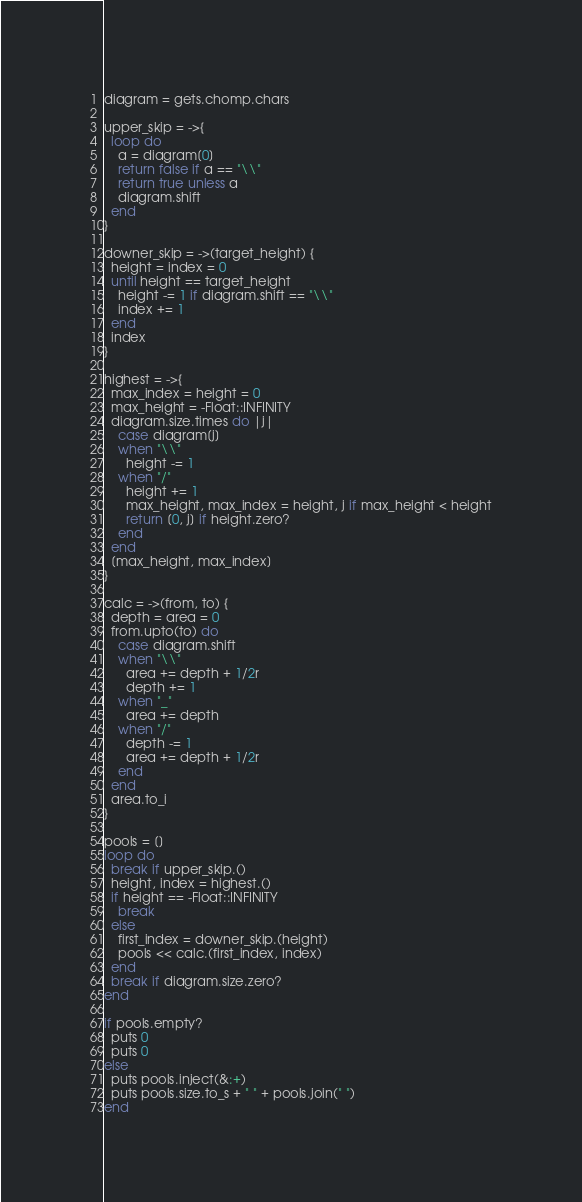Convert code to text. <code><loc_0><loc_0><loc_500><loc_500><_Ruby_>diagram = gets.chomp.chars

upper_skip = ->{
  loop do
    a = diagram[0]
    return false if a == "\\"
    return true unless a
    diagram.shift
  end
}

downer_skip = ->(target_height) {
  height = index = 0
  until height == target_height
    height -= 1 if diagram.shift == "\\"
    index += 1
  end
  index
}

highest = ->{
  max_index = height = 0
  max_height = -Float::INFINITY 
  diagram.size.times do |j|
    case diagram[j]
    when "\\"
      height -= 1
    when "/"
      height += 1
      max_height, max_index = height, j if max_height < height
      return [0, j] if height.zero?
    end
  end
  [max_height, max_index]
}

calc = ->(from, to) {
  depth = area = 0
  from.upto(to) do
    case diagram.shift
    when "\\"
      area += depth + 1/2r
      depth += 1
    when "_"
      area += depth
    when "/"
      depth -= 1
      area += depth + 1/2r
    end
  end
  area.to_i
}

pools = []
loop do
  break if upper_skip.()
  height, index = highest.()
  if height == -Float::INFINITY
    break
  else
    first_index = downer_skip.(height)
    pools << calc.(first_index, index)
  end
  break if diagram.size.zero?
end

if pools.empty?
  puts 0
  puts 0
else
  puts pools.inject(&:+)
  puts pools.size.to_s + " " + pools.join(" ")
end
</code> 